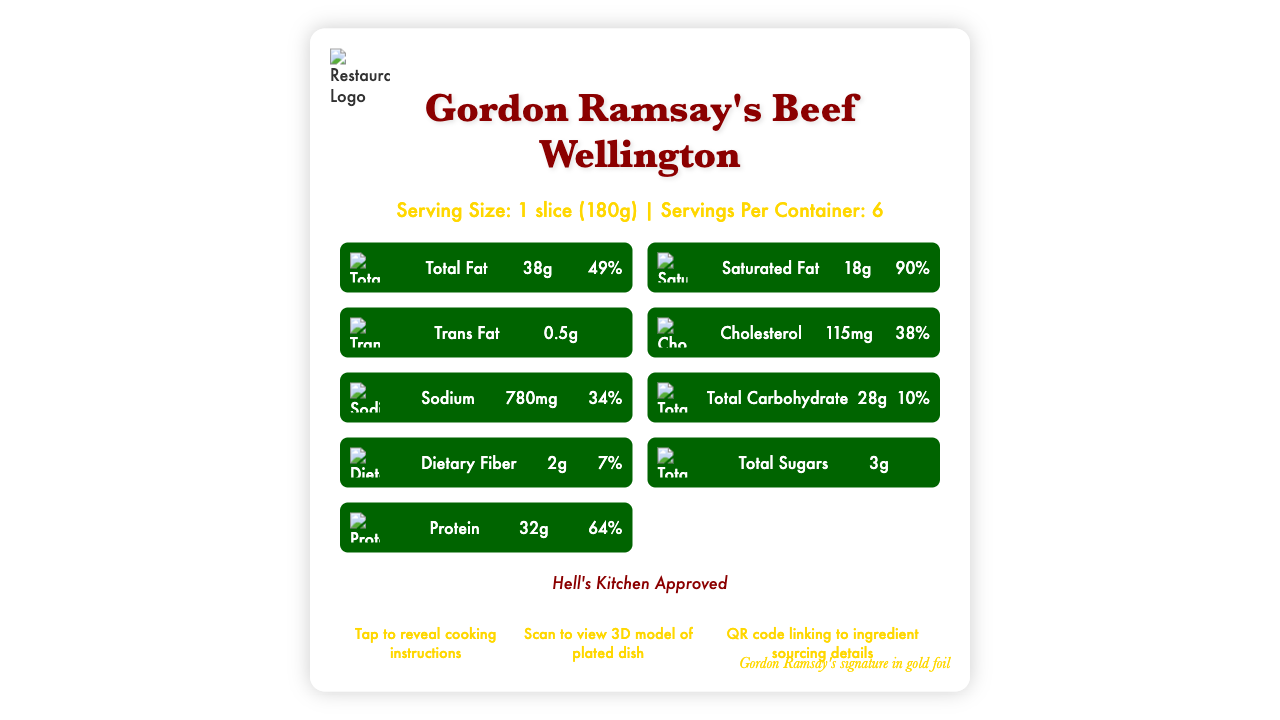What is the serving size for Gordon Ramsay's Beef Wellington? The serving size is explicitly mentioned at the top section of the document under the product name and serving information.
Answer: 1 slice (180g) How many servings are in a container? The number of servings per container is stated just below the serving size information.
Answer: 6 How many calories are in a serving of this dish? The calories per serving are listed under the serving information section.
Answer: 560 What percentage of the daily value of cholesterol is provided in one serving? The daily value percentage for cholesterol is listed in the nutrition facts section next to the amount 115mg.
Answer: 38% What's the total fat content per serving? The total fat content is listed under the nutrition facts section next to the daily value percentage of 49%.
Answer: 38g What is the icon used to represent protein? The design elements mention that the icon for protein is a seared beef tenderloin.
Answer: Seared beef tenderloin Which font is used for the headings? A. Arial B. Baskerville C. Futura The typography section specifies that the font used for headings is Baskerville.
Answer: B What is the primary color used in the design? A. #FFD700 B. #8B0000 C. #006400 The color scheme section indicates that the primary color is #8B0000.
Answer: B Does the document include animation features? The visual effects section confirms that there is an animation of steam rising from the Beef Wellington slice.
Answer: Yes Summarize the main design elements used in the Nutrition Facts Label for Gordon Ramsay's Beef Wellington. The details about the design elements are spread across different sections: background image, iconography, color scheme, typography, branding elements, and special features.
Answer: The design includes a rustic wooden background image, custom icons for nutrients, a primary color scheme of dark red, gold, and dark green, and typography with Baskerville and Futura fonts. It also features Gordon Ramsay's signature in gold foil, the restaurant logo, and special interactive features like AR and a QR code for sustainability info. Is Vitamin C content listed in the nutrition facts? The vitamin and mineral contents listed include Vitamin D, Calcium, Iron, and Potassium, but not Vitamin C.
Answer: No Describe one special feature included in the document. The special features section mentions various interactive elements, including a feature to tap and reveal cooking instructions.
Answer: Tap to reveal cooking instructions What is the texture overlay used in the background? The visual effects section mentions that the texture overlay in the background is a prosciutto pattern.
Answer: Prosciutto pattern How many grams of dietary fiber are in one serving? The dietary fiber content is listed under the nutrition facts section next to the daily value percentage of 7%.
Answer: 2g Is the sugar content information available? The total sugars content is stated as 3g in the nutrition facts, although no daily value percentage is provided.
Answer: Yes Which nutrient has the highest daily value percentage? The nutrition facts indicate that saturated fat has a daily value percentage of 90%, higher than any other listed nutrient.
Answer: Saturated Fat What is the secondary color in the color scheme? The color scheme section lists gold (#FFD700) as the secondary color.
Answer: Gold (#FFD700) What is the purpose of the QR code mentioned in the document? The special features section describes the QR code's purpose as linking to ingredient sourcing details.
Answer: Links to ingredient sourcing details If someone asks for the protein content in milligrams, can you provide an exact answer? The document provides the protein content only in grams (32g); it does not offer a value in milligrams.
Answer: Not enough information 